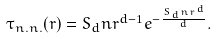Convert formula to latex. <formula><loc_0><loc_0><loc_500><loc_500>\tau _ { n . n . } ( r ) = S _ { d } n r ^ { d - 1 } e ^ { - \frac { S _ { d } n r ^ { d } } { d } } .</formula> 